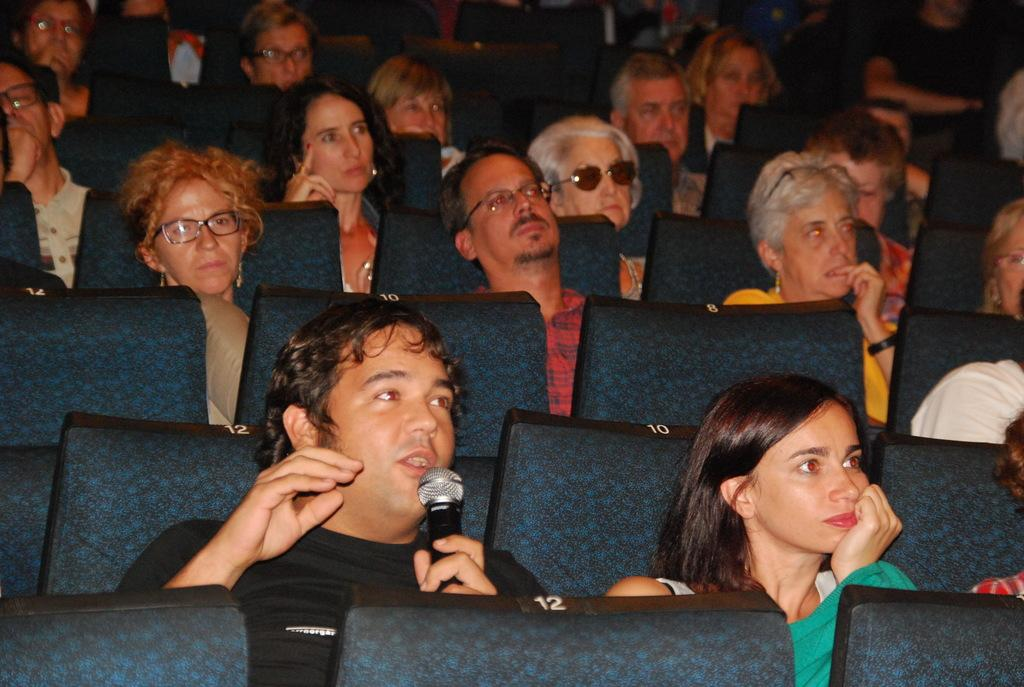What are the people in the image doing? The people in the image are sitting on chairs. Can you describe the activity of one of the individuals? Yes, a person is talking into a microphone. How many people are in the crowd in the image? There is no crowd present in the image; it only shows people sitting on chairs and one person talking into a microphone. 